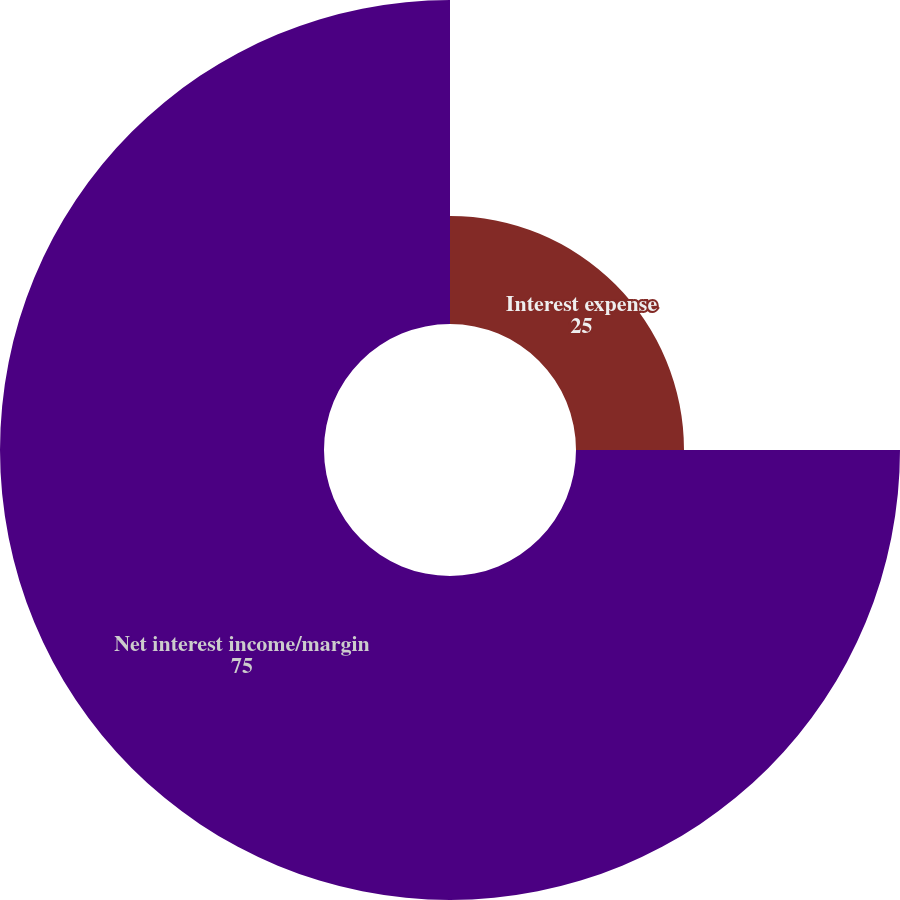<chart> <loc_0><loc_0><loc_500><loc_500><pie_chart><fcel>Interest expense<fcel>Net interest income/margin<nl><fcel>25.0%<fcel>75.0%<nl></chart> 